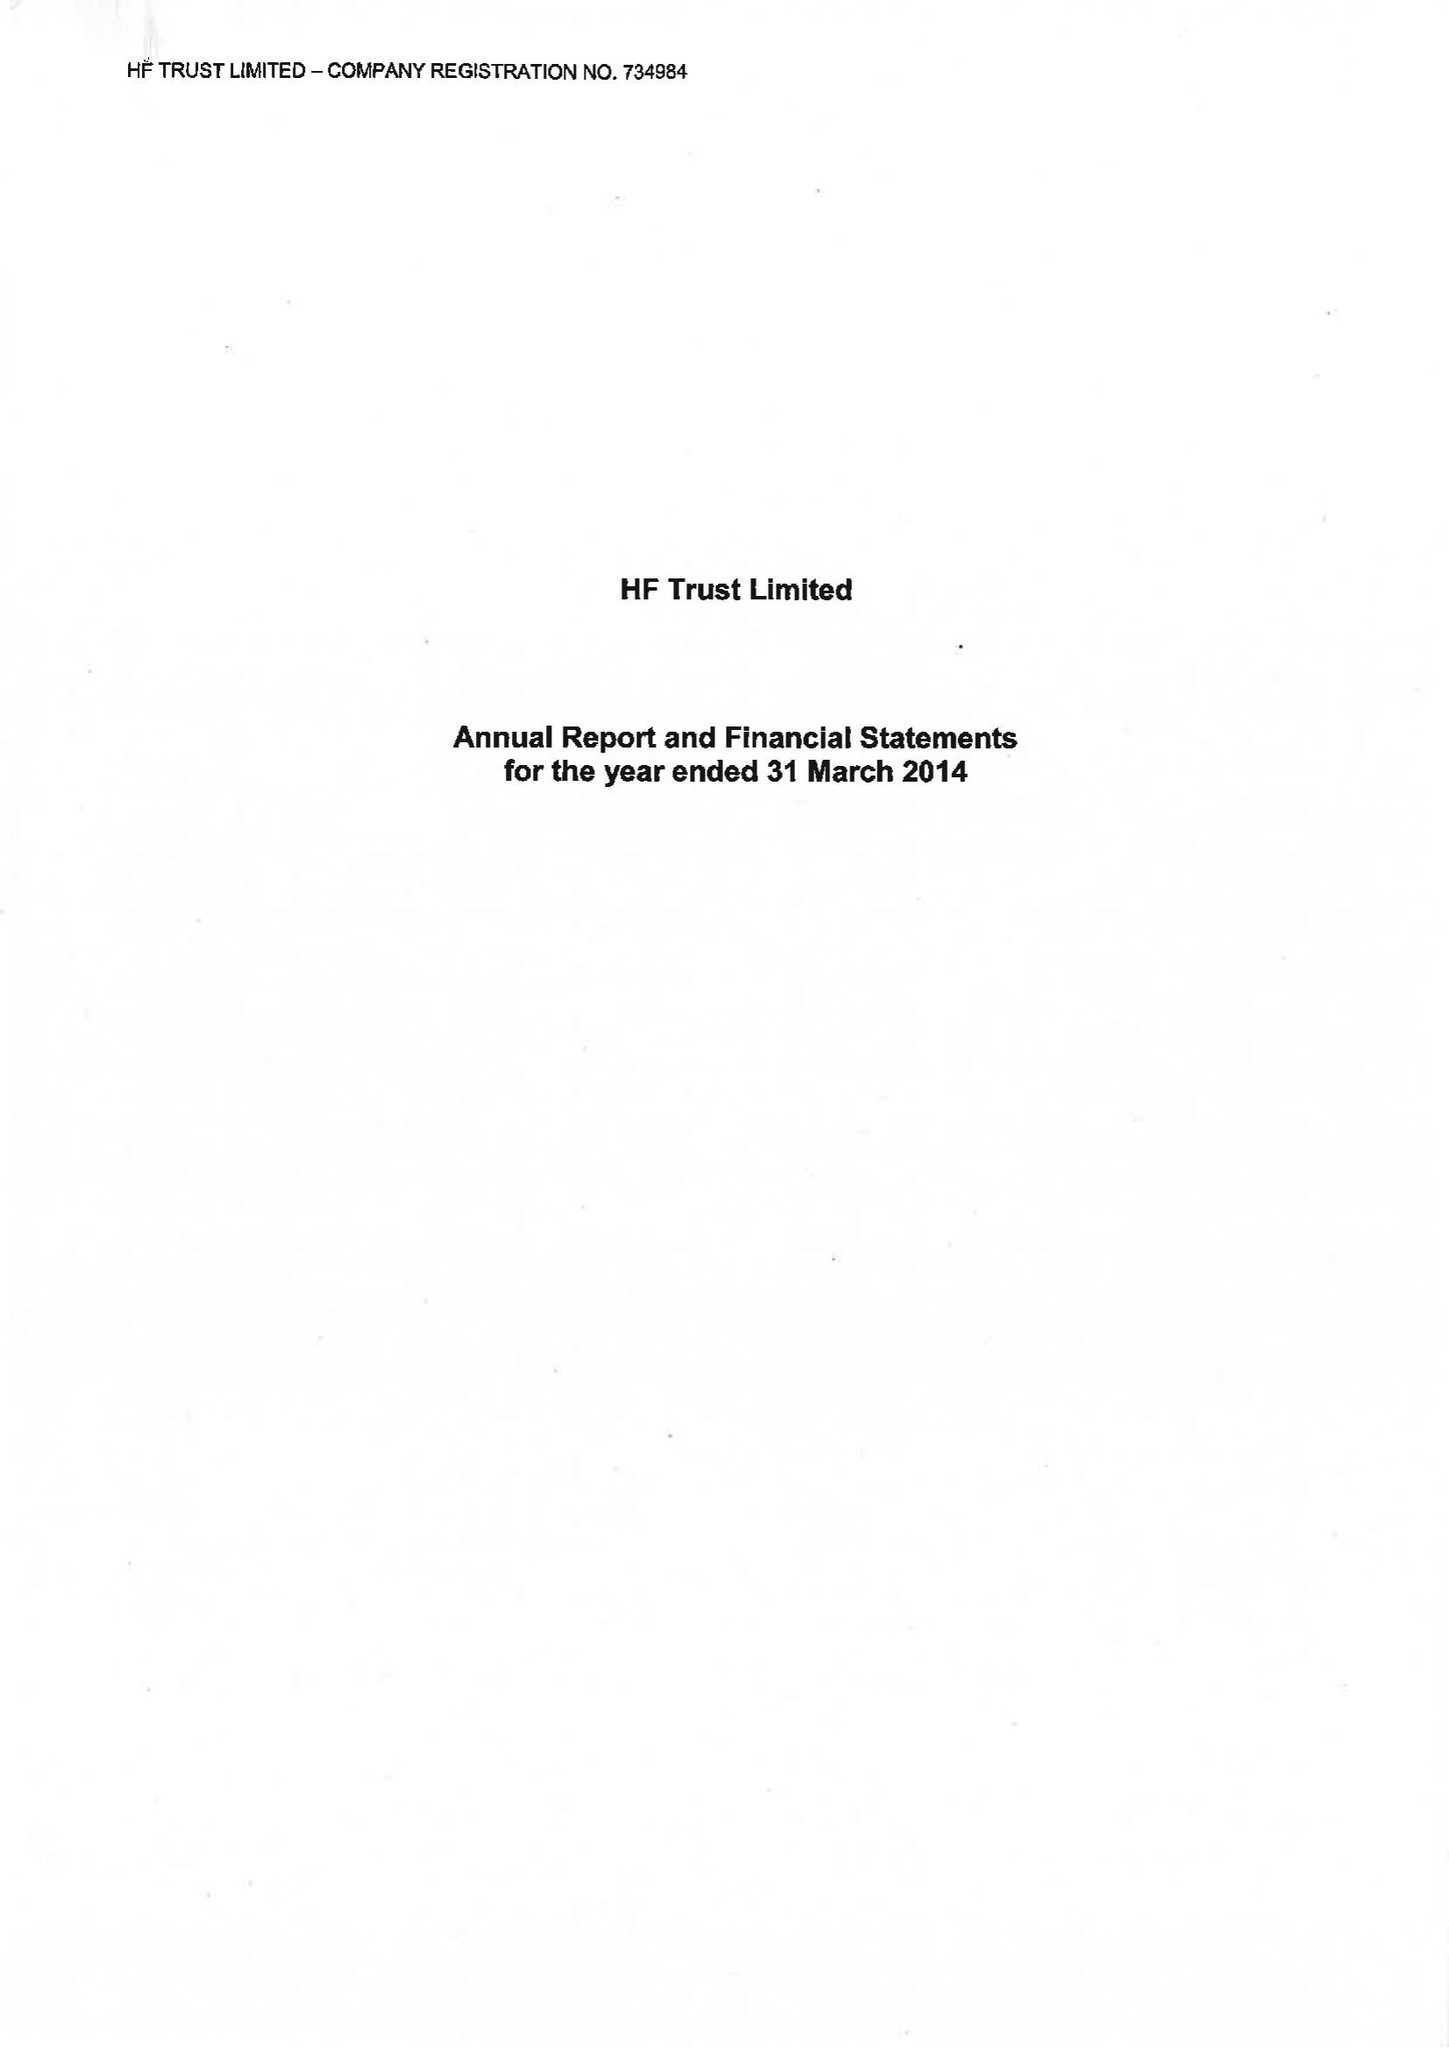What is the value for the charity_name?
Answer the question using a single word or phrase. Hf Trust Ltd. 